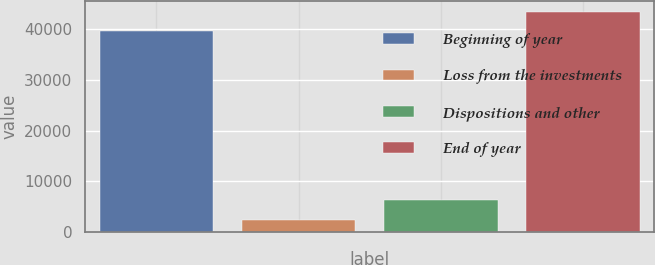Convert chart. <chart><loc_0><loc_0><loc_500><loc_500><bar_chart><fcel>Beginning of year<fcel>Loss from the investments<fcel>Dispositions and other<fcel>End of year<nl><fcel>39580<fcel>2469<fcel>6291.8<fcel>43402.8<nl></chart> 